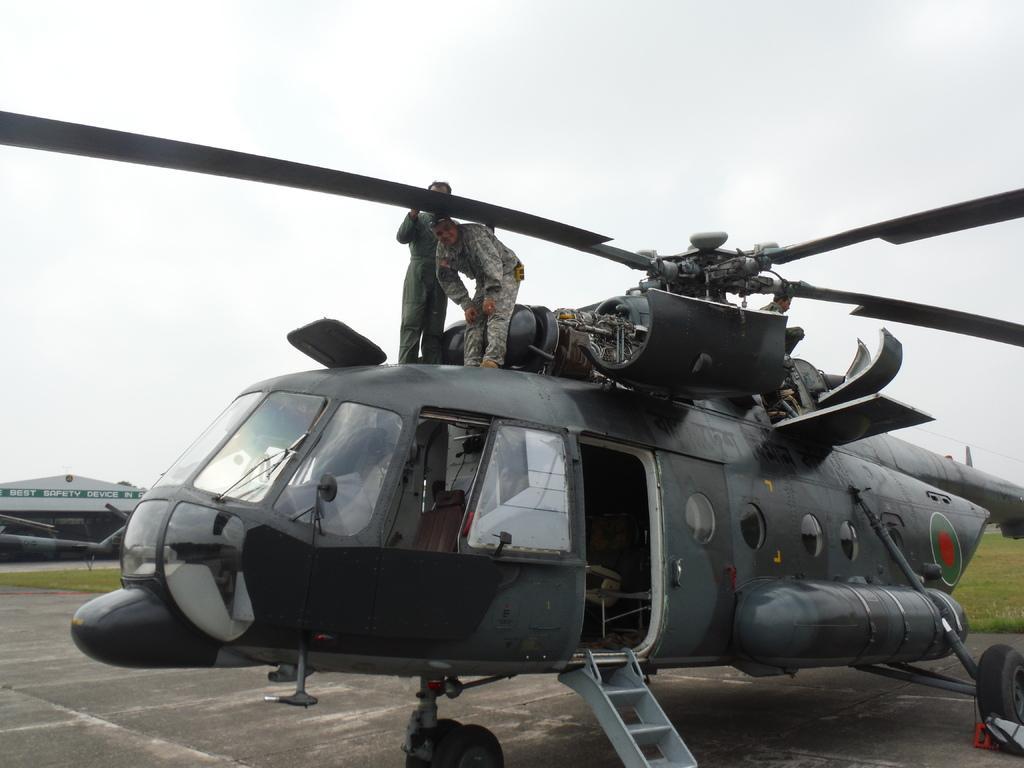How would you summarize this image in a sentence or two? As we can see in the image there are two people, plane, grass and on the top there is sky. 